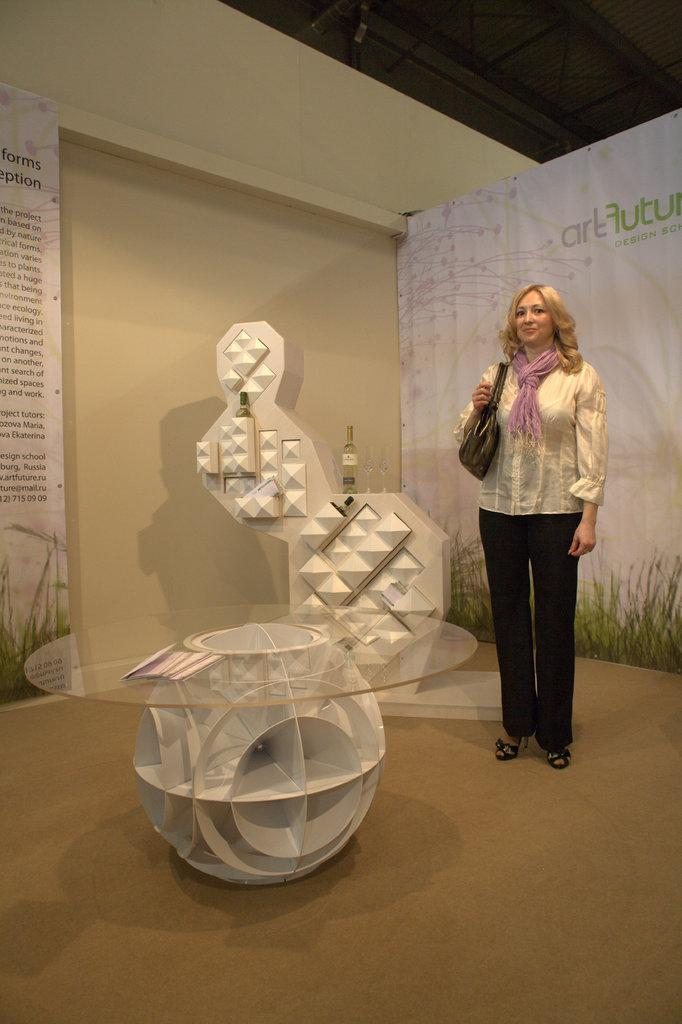Who or what is present in the image? There is a person in the image. What is the person wearing? The person is wearing a bag. What is behind the person? The person is standing in front of a banner. What objects are in front of the wall? There is a table and a rack in front of the wall. Can you see the iron in the image? There is no iron present in the image. What type of station is depicted in the image? There is no station present in the image. 